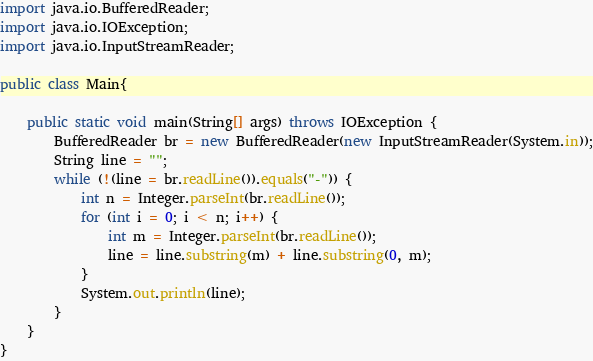<code> <loc_0><loc_0><loc_500><loc_500><_Java_>import java.io.BufferedReader;
import java.io.IOException;
import java.io.InputStreamReader;

public class Main{

    public static void main(String[] args) throws IOException {
        BufferedReader br = new BufferedReader(new InputStreamReader(System.in));
        String line = "";
        while (!(line = br.readLine()).equals("-")) {
            int n = Integer.parseInt(br.readLine());
            for (int i = 0; i < n; i++) {
                int m = Integer.parseInt(br.readLine());
                line = line.substring(m) + line.substring(0, m);
            }
            System.out.println(line);
        }
    }
}


</code> 